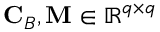Convert formula to latex. <formula><loc_0><loc_0><loc_500><loc_500>C _ { B } , M \in \mathbb { R } ^ { q \times q }</formula> 